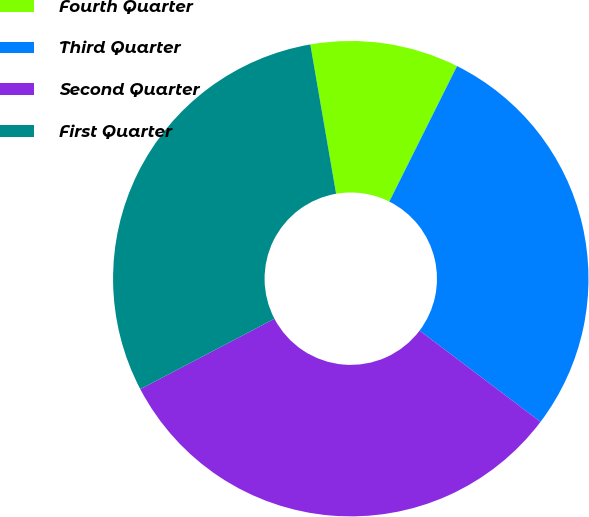Convert chart. <chart><loc_0><loc_0><loc_500><loc_500><pie_chart><fcel>Fourth Quarter<fcel>Third Quarter<fcel>Second Quarter<fcel>First Quarter<nl><fcel>10.1%<fcel>27.91%<fcel>32.02%<fcel>29.97%<nl></chart> 